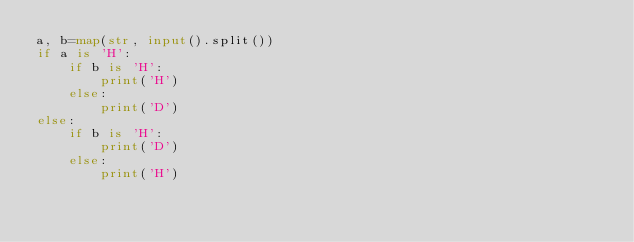Convert code to text. <code><loc_0><loc_0><loc_500><loc_500><_Python_>a, b=map(str, input().split())
if a is 'H':
    if b is 'H':
        print('H')
    else:
        print('D')
else:
    if b is 'H':
        print('D')
    else:
        print('H')
</code> 